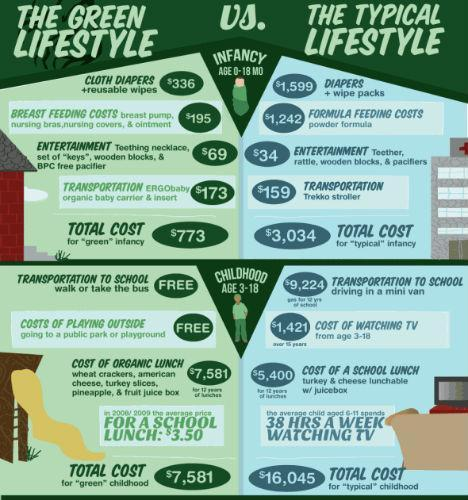What is the difference in total cost for green infancy vs typical infancy?
Answer the question with a short phrase. $2,261 By what amount is typical feeding costs more expensive than that in green infancy? $1,047 